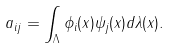Convert formula to latex. <formula><loc_0><loc_0><loc_500><loc_500>a _ { i j } = \int _ { \Lambda } \phi _ { i } ( x ) \psi _ { j } ( x ) d \lambda ( x ) .</formula> 